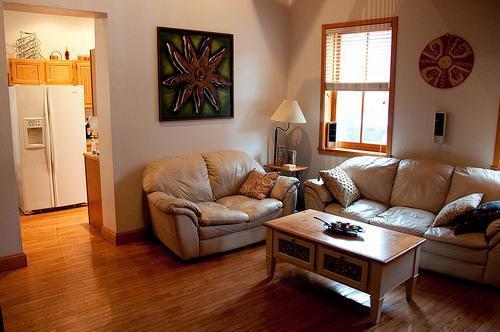How many pillows are on the furniture?
Give a very brief answer. 4. How many tables are in the living room?
Give a very brief answer. 2. How many things are hanging on the walls?
Give a very brief answer. 3. 